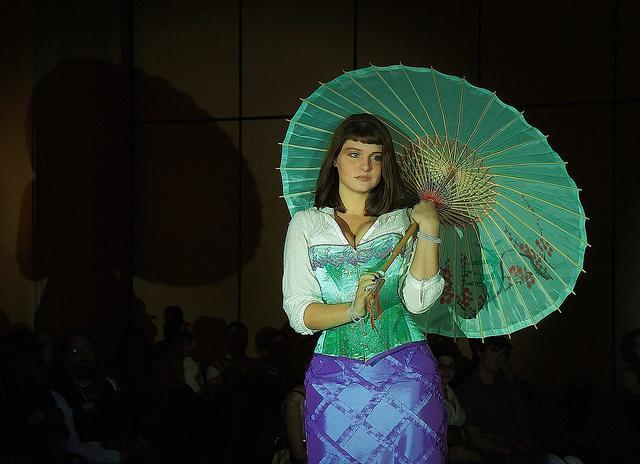How many people are there?
Give a very brief answer. 4. 